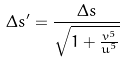Convert formula to latex. <formula><loc_0><loc_0><loc_500><loc_500>\Delta s ^ { \prime } = \frac { \Delta s } { \sqrt { 1 + \frac { v ^ { 5 } } { u ^ { 5 } } } }</formula> 